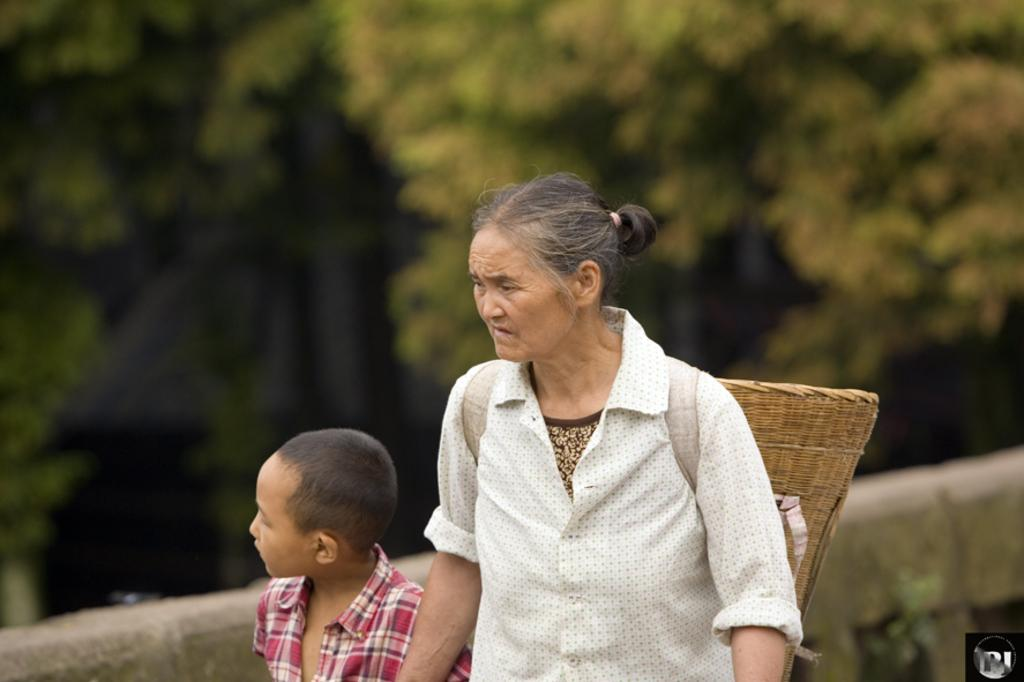How many people are in the image? There are people in the image, but the exact number is not specified. What is one person wearing that is unusual? One person is wearing a basket. What can be seen in the background of the image? There are trees and a wall visible in the background. What type of knot is being tied by the person in the image? There is no indication in the image that anyone is tying a knot. Can you describe the lamp that is present in the image? There is no lamp present in the image. 